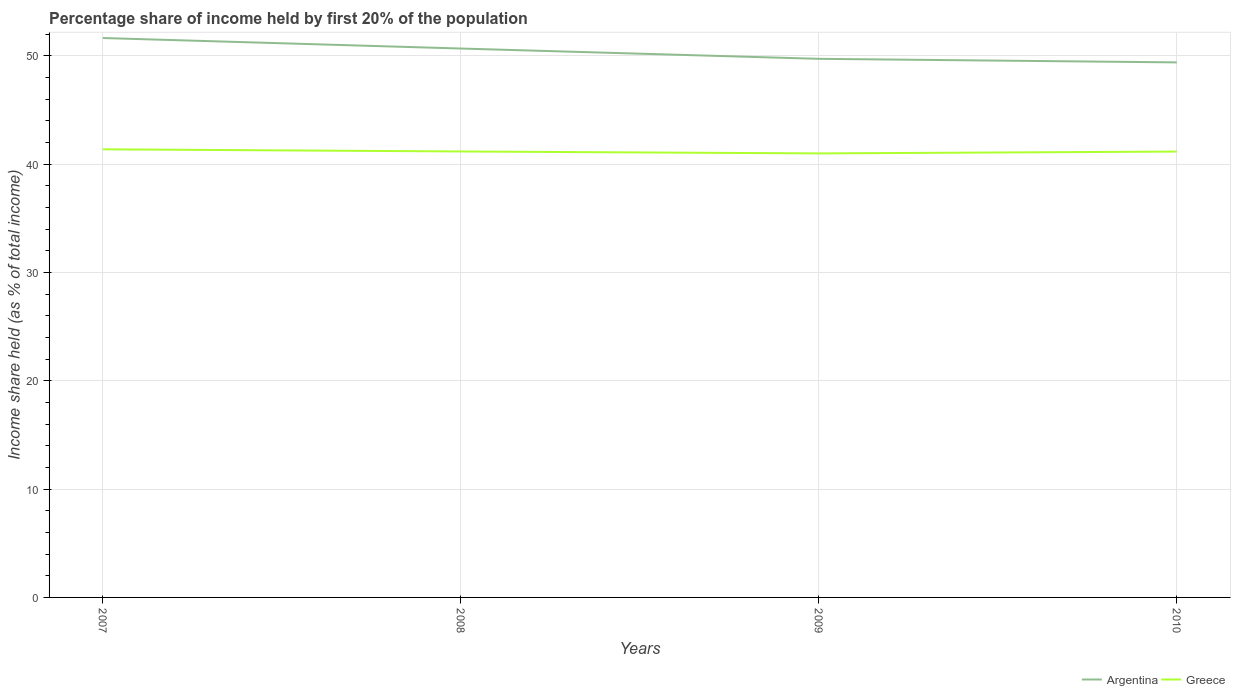Does the line corresponding to Argentina intersect with the line corresponding to Greece?
Keep it short and to the point. No. Is the number of lines equal to the number of legend labels?
Your response must be concise. Yes. Across all years, what is the maximum share of income held by first 20% of the population in Argentina?
Keep it short and to the point. 49.38. In which year was the share of income held by first 20% of the population in Argentina maximum?
Your answer should be very brief. 2010. What is the total share of income held by first 20% of the population in Argentina in the graph?
Provide a short and direct response. 2.25. What is the difference between the highest and the second highest share of income held by first 20% of the population in Argentina?
Provide a succinct answer. 2.25. What is the difference between the highest and the lowest share of income held by first 20% of the population in Greece?
Offer a terse response. 1. Is the share of income held by first 20% of the population in Greece strictly greater than the share of income held by first 20% of the population in Argentina over the years?
Offer a very short reply. Yes. How many lines are there?
Offer a very short reply. 2. How many years are there in the graph?
Offer a very short reply. 4. Does the graph contain grids?
Offer a terse response. Yes. How are the legend labels stacked?
Offer a very short reply. Horizontal. What is the title of the graph?
Offer a terse response. Percentage share of income held by first 20% of the population. Does "Singapore" appear as one of the legend labels in the graph?
Keep it short and to the point. No. What is the label or title of the Y-axis?
Provide a short and direct response. Income share held (as % of total income). What is the Income share held (as % of total income) of Argentina in 2007?
Offer a terse response. 51.63. What is the Income share held (as % of total income) in Greece in 2007?
Your response must be concise. 41.36. What is the Income share held (as % of total income) in Argentina in 2008?
Offer a very short reply. 50.66. What is the Income share held (as % of total income) of Greece in 2008?
Ensure brevity in your answer.  41.16. What is the Income share held (as % of total income) of Argentina in 2009?
Offer a terse response. 49.71. What is the Income share held (as % of total income) in Greece in 2009?
Provide a succinct answer. 40.98. What is the Income share held (as % of total income) of Argentina in 2010?
Your answer should be very brief. 49.38. What is the Income share held (as % of total income) of Greece in 2010?
Provide a succinct answer. 41.15. Across all years, what is the maximum Income share held (as % of total income) of Argentina?
Provide a short and direct response. 51.63. Across all years, what is the maximum Income share held (as % of total income) in Greece?
Offer a terse response. 41.36. Across all years, what is the minimum Income share held (as % of total income) of Argentina?
Offer a terse response. 49.38. Across all years, what is the minimum Income share held (as % of total income) in Greece?
Keep it short and to the point. 40.98. What is the total Income share held (as % of total income) of Argentina in the graph?
Your answer should be very brief. 201.38. What is the total Income share held (as % of total income) in Greece in the graph?
Give a very brief answer. 164.65. What is the difference between the Income share held (as % of total income) of Argentina in 2007 and that in 2008?
Keep it short and to the point. 0.97. What is the difference between the Income share held (as % of total income) in Argentina in 2007 and that in 2009?
Provide a short and direct response. 1.92. What is the difference between the Income share held (as % of total income) in Greece in 2007 and that in 2009?
Provide a succinct answer. 0.38. What is the difference between the Income share held (as % of total income) in Argentina in 2007 and that in 2010?
Make the answer very short. 2.25. What is the difference between the Income share held (as % of total income) in Greece in 2007 and that in 2010?
Offer a terse response. 0.21. What is the difference between the Income share held (as % of total income) of Greece in 2008 and that in 2009?
Offer a terse response. 0.18. What is the difference between the Income share held (as % of total income) of Argentina in 2008 and that in 2010?
Make the answer very short. 1.28. What is the difference between the Income share held (as % of total income) in Argentina in 2009 and that in 2010?
Give a very brief answer. 0.33. What is the difference between the Income share held (as % of total income) in Greece in 2009 and that in 2010?
Make the answer very short. -0.17. What is the difference between the Income share held (as % of total income) of Argentina in 2007 and the Income share held (as % of total income) of Greece in 2008?
Offer a very short reply. 10.47. What is the difference between the Income share held (as % of total income) of Argentina in 2007 and the Income share held (as % of total income) of Greece in 2009?
Your response must be concise. 10.65. What is the difference between the Income share held (as % of total income) of Argentina in 2007 and the Income share held (as % of total income) of Greece in 2010?
Make the answer very short. 10.48. What is the difference between the Income share held (as % of total income) of Argentina in 2008 and the Income share held (as % of total income) of Greece in 2009?
Keep it short and to the point. 9.68. What is the difference between the Income share held (as % of total income) of Argentina in 2008 and the Income share held (as % of total income) of Greece in 2010?
Keep it short and to the point. 9.51. What is the difference between the Income share held (as % of total income) in Argentina in 2009 and the Income share held (as % of total income) in Greece in 2010?
Your response must be concise. 8.56. What is the average Income share held (as % of total income) in Argentina per year?
Provide a succinct answer. 50.34. What is the average Income share held (as % of total income) of Greece per year?
Your answer should be compact. 41.16. In the year 2007, what is the difference between the Income share held (as % of total income) in Argentina and Income share held (as % of total income) in Greece?
Your response must be concise. 10.27. In the year 2008, what is the difference between the Income share held (as % of total income) in Argentina and Income share held (as % of total income) in Greece?
Ensure brevity in your answer.  9.5. In the year 2009, what is the difference between the Income share held (as % of total income) of Argentina and Income share held (as % of total income) of Greece?
Your answer should be compact. 8.73. In the year 2010, what is the difference between the Income share held (as % of total income) in Argentina and Income share held (as % of total income) in Greece?
Offer a terse response. 8.23. What is the ratio of the Income share held (as % of total income) of Argentina in 2007 to that in 2008?
Provide a short and direct response. 1.02. What is the ratio of the Income share held (as % of total income) in Argentina in 2007 to that in 2009?
Your response must be concise. 1.04. What is the ratio of the Income share held (as % of total income) in Greece in 2007 to that in 2009?
Offer a terse response. 1.01. What is the ratio of the Income share held (as % of total income) in Argentina in 2007 to that in 2010?
Make the answer very short. 1.05. What is the ratio of the Income share held (as % of total income) of Argentina in 2008 to that in 2009?
Your answer should be very brief. 1.02. What is the ratio of the Income share held (as % of total income) of Argentina in 2008 to that in 2010?
Make the answer very short. 1.03. What is the ratio of the Income share held (as % of total income) in Greece in 2008 to that in 2010?
Your answer should be very brief. 1. What is the ratio of the Income share held (as % of total income) in Greece in 2009 to that in 2010?
Keep it short and to the point. 1. What is the difference between the highest and the lowest Income share held (as % of total income) of Argentina?
Your answer should be very brief. 2.25. What is the difference between the highest and the lowest Income share held (as % of total income) in Greece?
Offer a terse response. 0.38. 